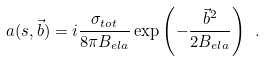Convert formula to latex. <formula><loc_0><loc_0><loc_500><loc_500>a ( s , \vec { b } ) = i \frac { \sigma _ { t o t } } { 8 \pi B _ { e l a } } \exp \left ( - \frac { { \vec { b } } ^ { 2 } } { 2 B _ { e l a } } \right ) \ .</formula> 